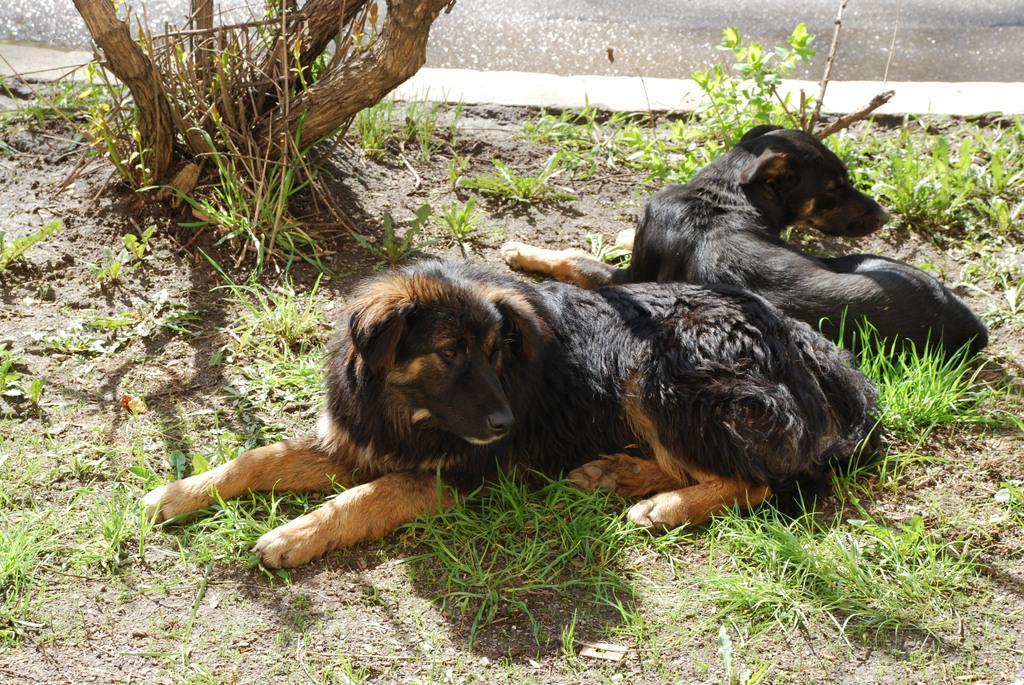Can you describe this image briefly? In this image on the floor there are two dogs, plants, grasses. In the background there is water body and tree. 